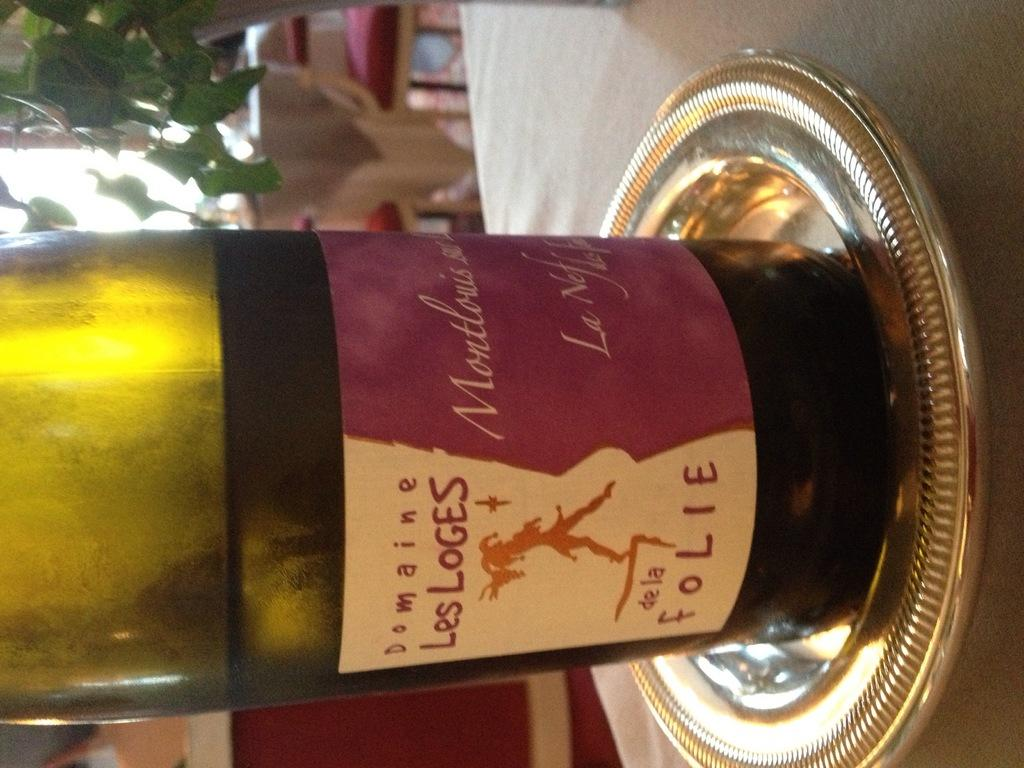<image>
Describe the image concisely. a bottle of Les Loges that is on a silver plate 